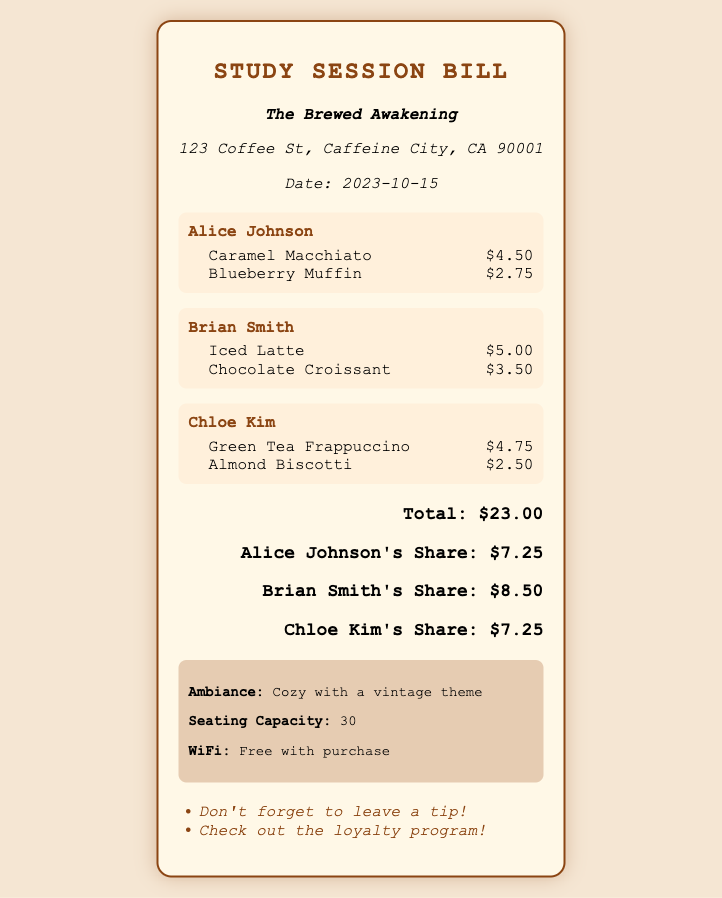What is the total amount of the bill? The total amount of the bill is listed in the document under the total section.
Answer: $23.00 Who ordered the Iced Latte? The document states which member ordered which item. Brian Smith ordered the Iced Latte.
Answer: Brian Smith What is Alice Johnson's share of the bill? The share section specifies how much each member is responsible for. Alice Johnson's share is $7.25.
Answer: $7.25 What food item did Chloe Kim order? By reviewing Chloe Kim's section, we can identify the items she ordered. She ordered an Almond Biscotti.
Answer: Almond Biscotti How many people participated in the bill? The member sections indicate how many individuals are included in the bill. There are three members listed.
Answer: 3 What is the ambiance of the coffee shop? The ambiance section provides an overview of the coffee shop's atmosphere. It is described as cozy with a vintage theme.
Answer: Cozy with a vintage theme What type of seating capacity is mentioned? The decorations section provides information about the seating arrangement of the shop. The capacity is listed in the document.
Answer: 30 What reminder is given regarding tips? The reminders section contains notes for patrons, specifically regarding gratuity. It mentions not to forget to leave a tip.
Answer: Don't forget to leave a tip! 